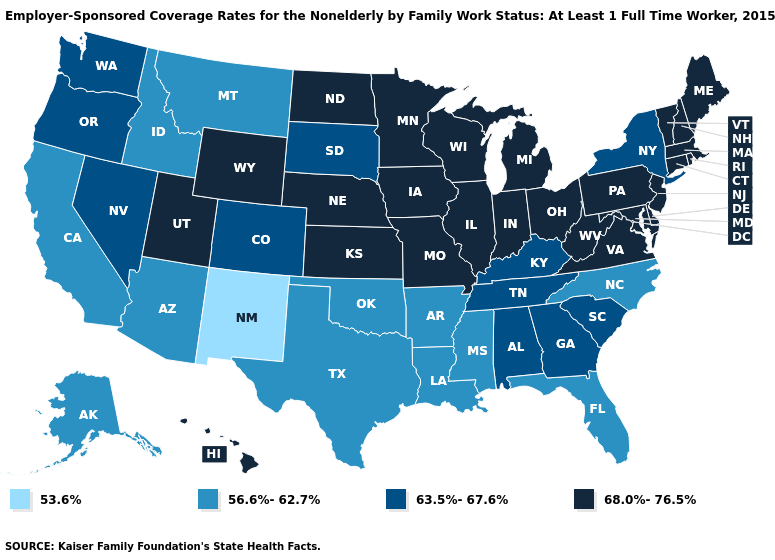What is the value of Kansas?
Quick response, please. 68.0%-76.5%. Name the states that have a value in the range 63.5%-67.6%?
Short answer required. Alabama, Colorado, Georgia, Kentucky, Nevada, New York, Oregon, South Carolina, South Dakota, Tennessee, Washington. What is the lowest value in states that border Oregon?
Concise answer only. 56.6%-62.7%. Does Ohio have a higher value than Florida?
Give a very brief answer. Yes. Among the states that border Arkansas , which have the highest value?
Write a very short answer. Missouri. What is the highest value in the USA?
Be succinct. 68.0%-76.5%. Among the states that border Nevada , which have the lowest value?
Short answer required. Arizona, California, Idaho. What is the value of Illinois?
Quick response, please. 68.0%-76.5%. What is the highest value in the USA?
Be succinct. 68.0%-76.5%. Name the states that have a value in the range 56.6%-62.7%?
Write a very short answer. Alaska, Arizona, Arkansas, California, Florida, Idaho, Louisiana, Mississippi, Montana, North Carolina, Oklahoma, Texas. Name the states that have a value in the range 68.0%-76.5%?
Be succinct. Connecticut, Delaware, Hawaii, Illinois, Indiana, Iowa, Kansas, Maine, Maryland, Massachusetts, Michigan, Minnesota, Missouri, Nebraska, New Hampshire, New Jersey, North Dakota, Ohio, Pennsylvania, Rhode Island, Utah, Vermont, Virginia, West Virginia, Wisconsin, Wyoming. Name the states that have a value in the range 68.0%-76.5%?
Write a very short answer. Connecticut, Delaware, Hawaii, Illinois, Indiana, Iowa, Kansas, Maine, Maryland, Massachusetts, Michigan, Minnesota, Missouri, Nebraska, New Hampshire, New Jersey, North Dakota, Ohio, Pennsylvania, Rhode Island, Utah, Vermont, Virginia, West Virginia, Wisconsin, Wyoming. Does Arizona have a lower value than Arkansas?
Short answer required. No. Name the states that have a value in the range 56.6%-62.7%?
Short answer required. Alaska, Arizona, Arkansas, California, Florida, Idaho, Louisiana, Mississippi, Montana, North Carolina, Oklahoma, Texas. 